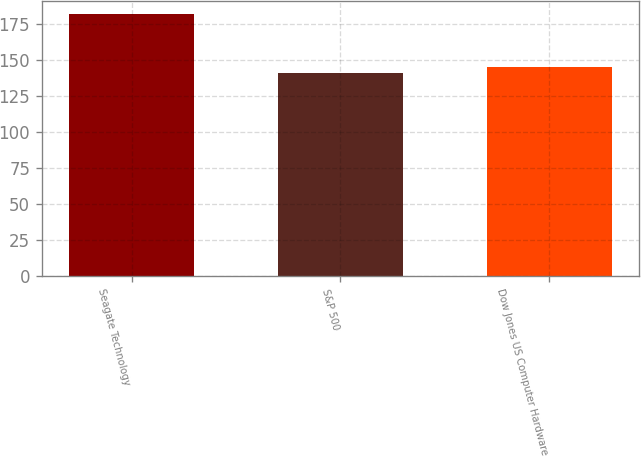Convert chart to OTSL. <chart><loc_0><loc_0><loc_500><loc_500><bar_chart><fcel>Seagate Technology<fcel>S&P 500<fcel>Dow Jones US Computer Hardware<nl><fcel>181.98<fcel>140.9<fcel>145.01<nl></chart> 